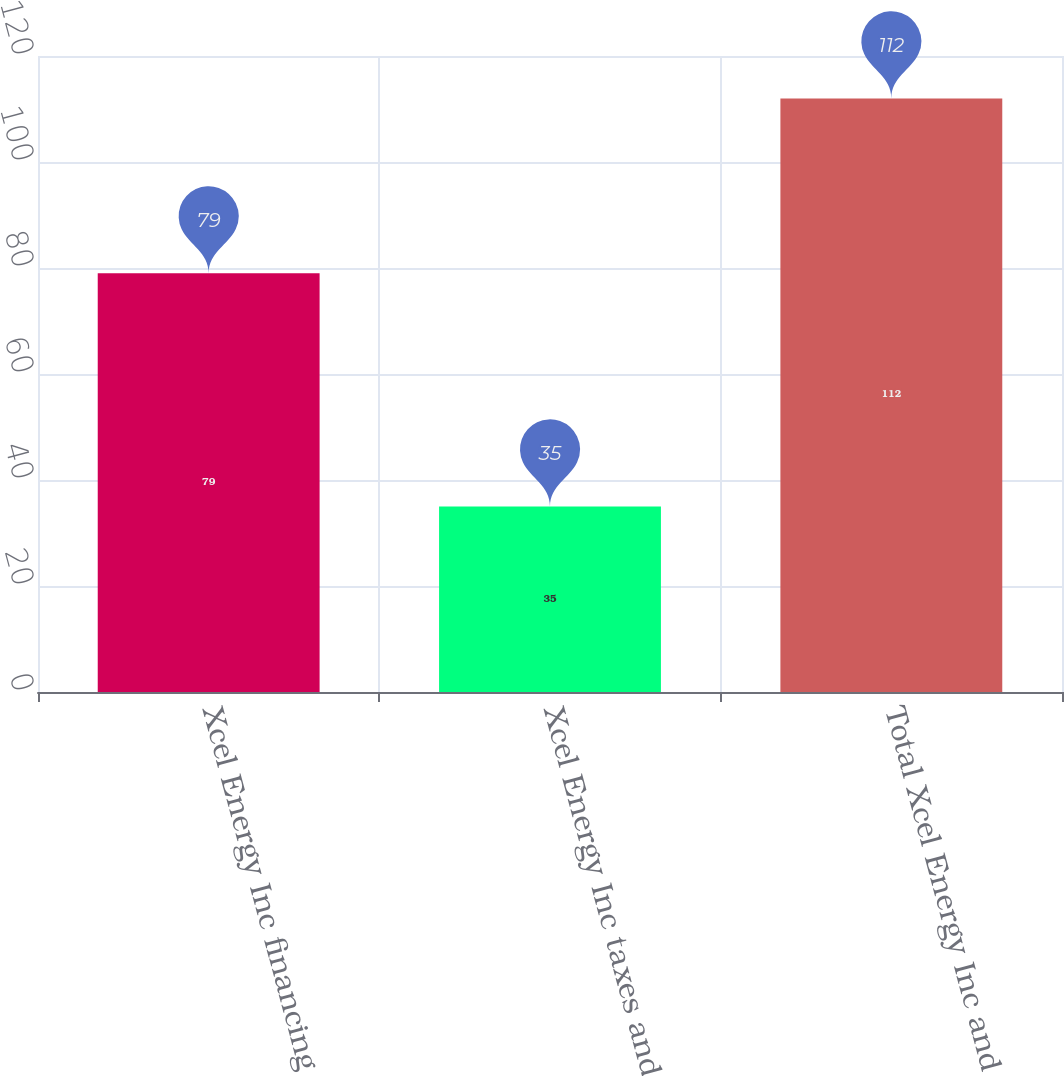Convert chart. <chart><loc_0><loc_0><loc_500><loc_500><bar_chart><fcel>Xcel Energy Inc financing<fcel>Xcel Energy Inc taxes and<fcel>Total Xcel Energy Inc and<nl><fcel>79<fcel>35<fcel>112<nl></chart> 